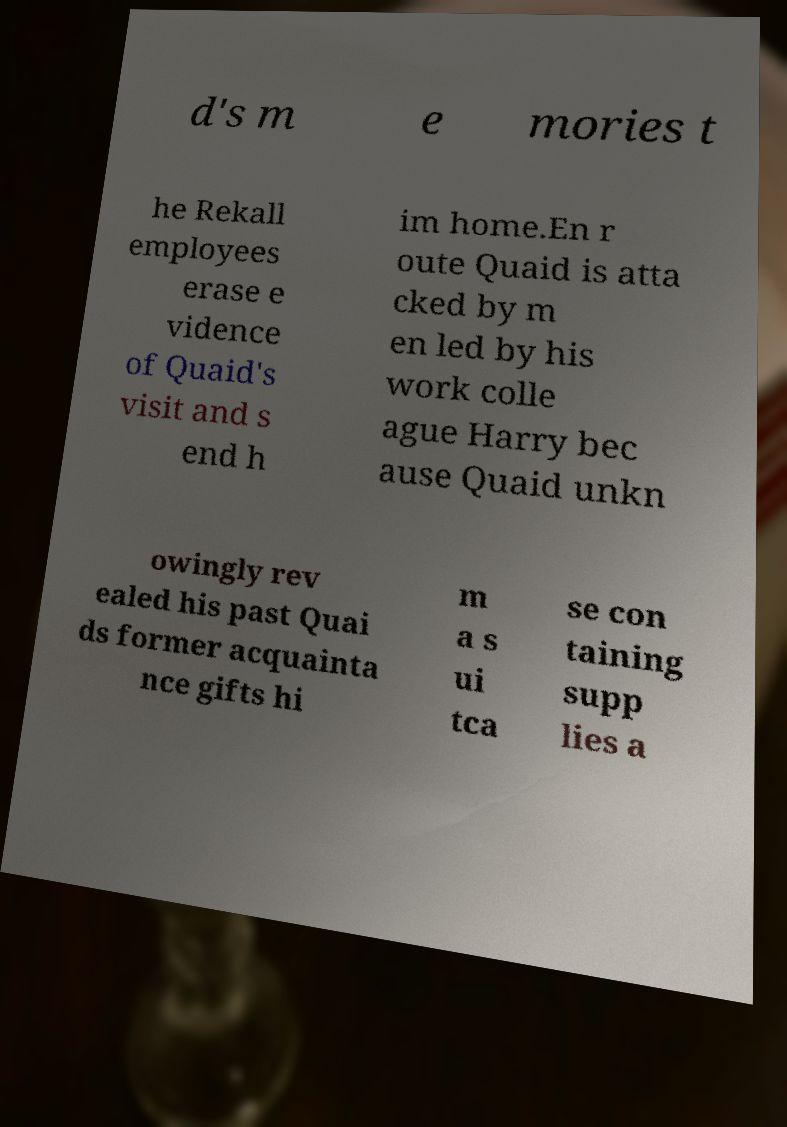What messages or text are displayed in this image? I need them in a readable, typed format. d's m e mories t he Rekall employees erase e vidence of Quaid's visit and s end h im home.En r oute Quaid is atta cked by m en led by his work colle ague Harry bec ause Quaid unkn owingly rev ealed his past Quai ds former acquainta nce gifts hi m a s ui tca se con taining supp lies a 